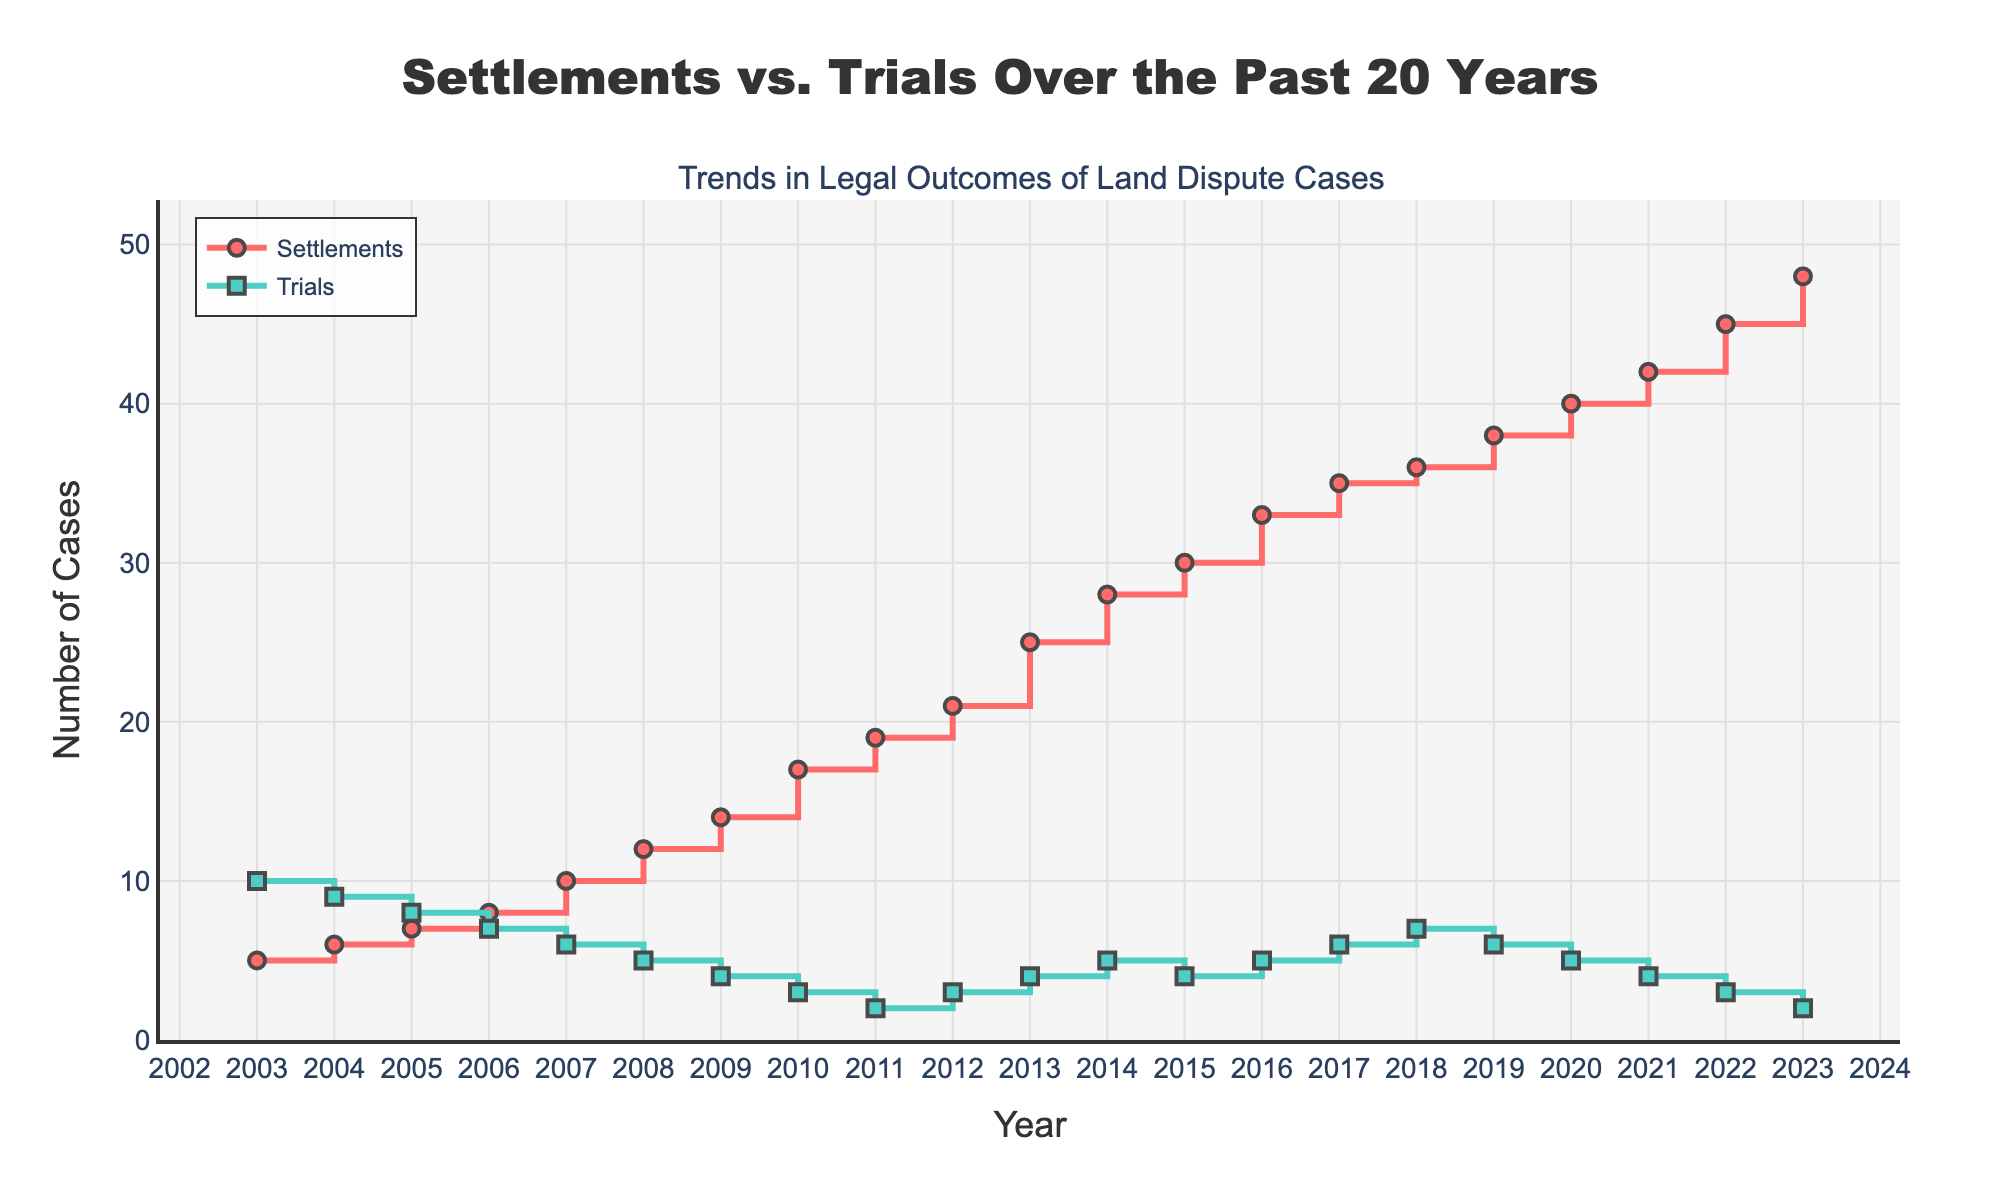What are the two categories of legal outcomes shown in the plot? The plot includes two lines, each representing a different category of legal outcomes. From the figure's legend, we can see that one line is labeled "Settlements" and the other is labeled "Trials".
Answer: Settlements and Trials What does the y-axis represent? The y-axis of the plot includes labels that indicate the number of cases. This is clear from the axis title "Number of Cases".
Answer: Number of Cases Which year had the highest number of trial cases? By analyzing the plot, the highest point on the "Trials" line occurs in 2003, indicating the number of trials was highest in that year. This can be verified by the y-values on the "Trials" line in the plot.
Answer: 2003 How many more settlements were there in 2023 compared to 2003? According to the plot, the number of settlements in 2023 is 48 and in 2003 is 5. The difference is calculated as 48 - 5 = 43.
Answer: 43 In which year did the number of settlements surpass 15? By examining the rising "Settlements" line on the plot, it surpasses the y-value of 15 between the years 2008 and 2009. Thus, the first year it surpasses 15 is 2009.
Answer: 2009 What is the average number of settlement cases between 2003 and 2023? To find the average, sum the number of settlement cases for all years and divide by the number of years (21 years). The sum is \[ 5 + 6 + 7 + 8 + 10 + 12 + 14 + 17 + 19 + 21 + 25 + 28 + 30 + 33 + 35 + 36 + 38 + 40 + 42 + 45 + 48 \] = 461. The average is 461 / 21 ≈ 21.95.
Answer: 21.95 How did the number of trial cases change from 2010 to 2015? The number of trial cases in 2010 is 3 and in 2015 it is 4. Although there is a slight decrease and increase within these years, the overall change is: 4 - 3 = 1.
Answer: Increased by 1 Which category has a generally declining trend over the years? By observing the overall direction and slope of the lines in the plot, the "Trials" line has a generally declining trend over the years, while the "Settlements" line increases.
Answer: Trials How many total cases were there in 2013? In 2013, the number of settlement cases was 25 and trials were 4. Adding these gives 25 + 4 = 29 total cases.
Answer: 29 